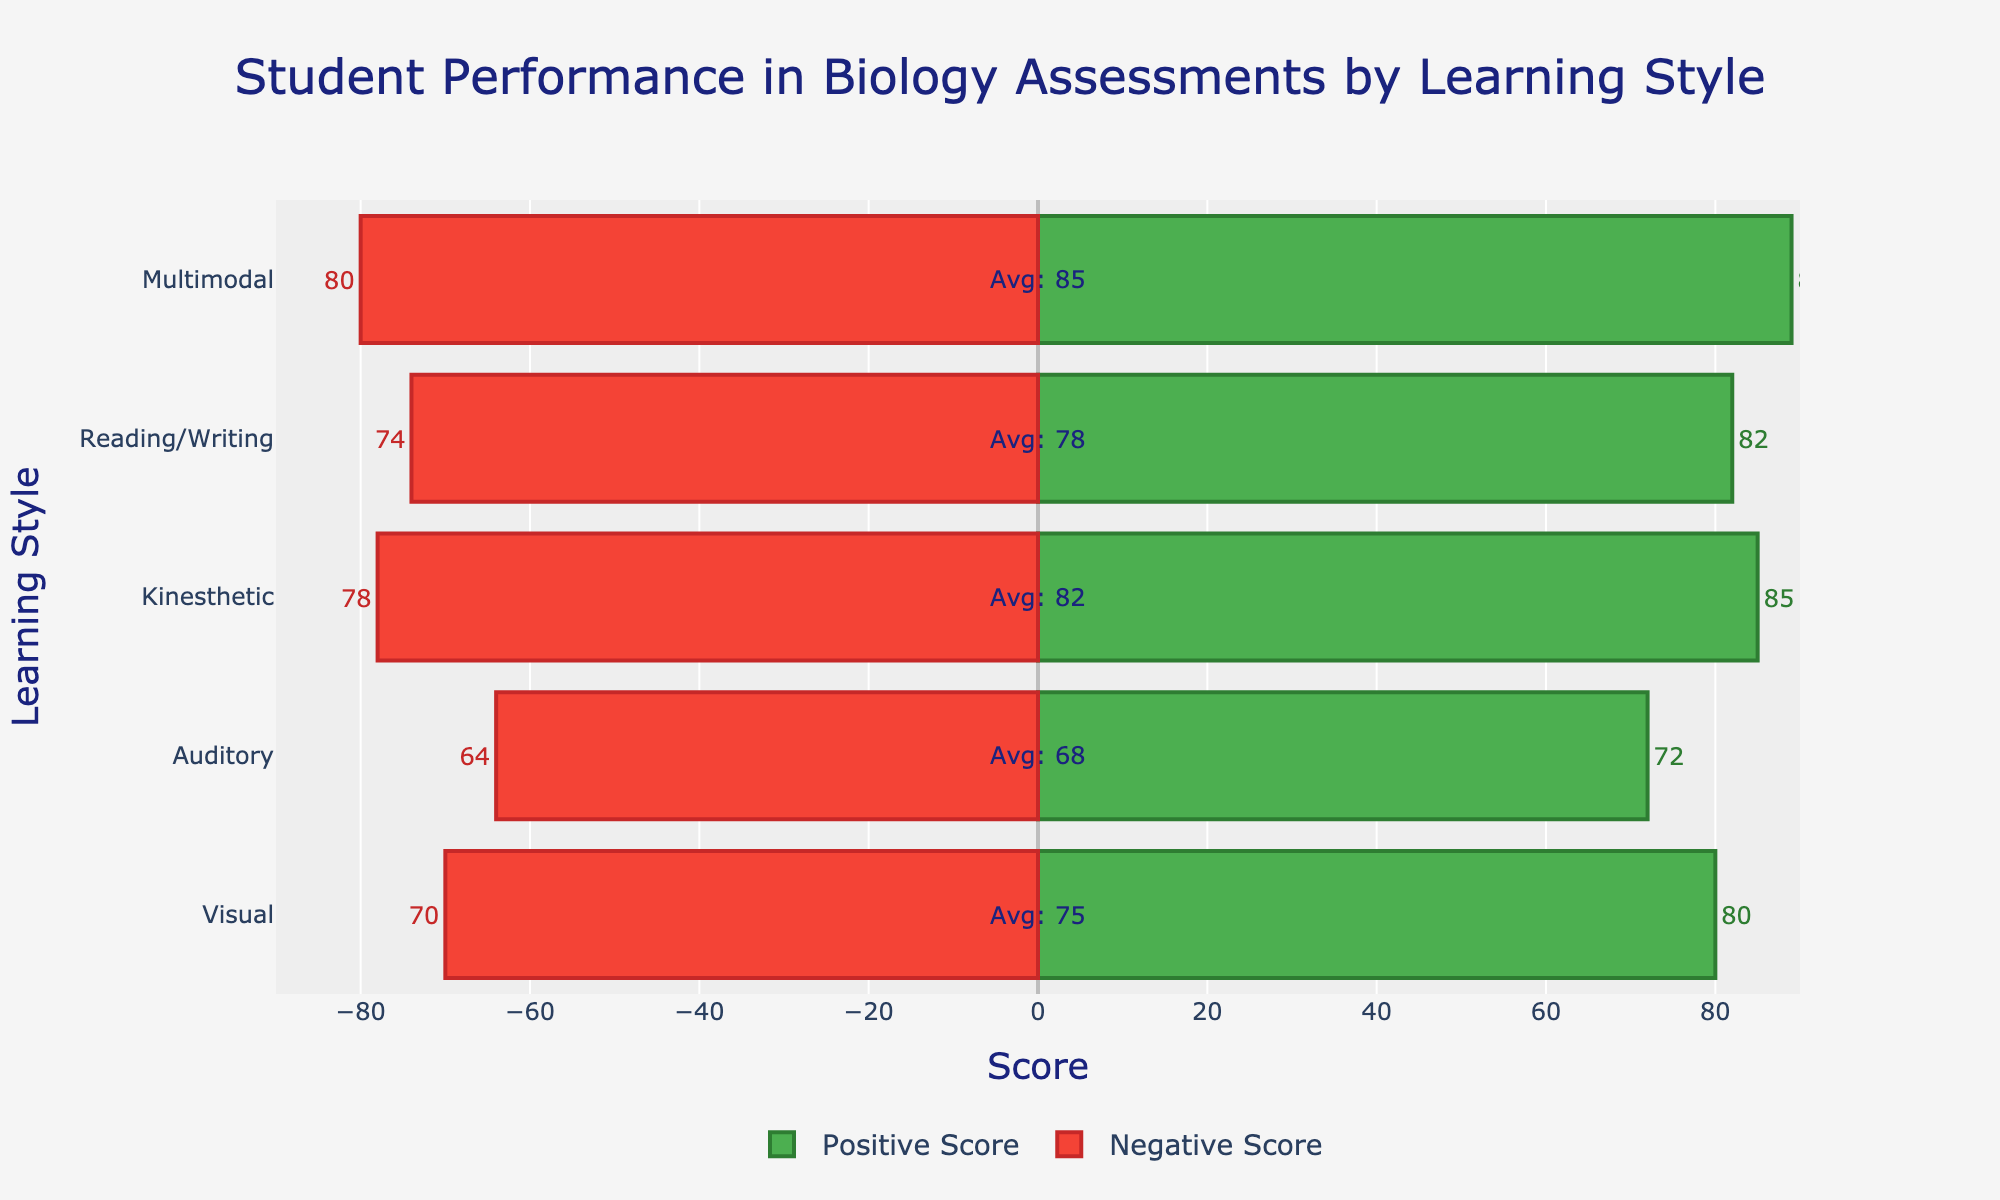What's the average score of the Kinesthetic learning style? The average score is directly annotated next to the Kinesthetic learning style bar.
Answer: 82 Which learning style has the highest positive score? The bar representing the highest positive score is the longest green bar, which is for the Multimodal learning style.
Answer: Multimodal What is the difference between the positive score and negative score of the Auditory learning style? Subtract the negative score of the Auditory learning style from its positive score: 72 - 64 = 8.
Answer: 8 Which learning style has the smallest difference between positive and negative scores? Calculate the difference for each learning style and find the smallest: 
Visual: 80 - 70 = 10 
Auditory: 72 - 64 = 8 
Kinesthetic: 85 - 78 = 7 
Reading/Writing: 82 - 74 = 8 
Multimodal: 89 - 80 = 9. The smallest difference is for the Kinesthetic learning style.
Answer: Kinesthetic Which learning style has the lowest average score? The bar with the lowest average score annotation is for the Auditory learning style.
Answer: Auditory How does the negative score of the visual learning style compare to the average score of the auditory learning style? The negative score of the Visual learning style (70) is greater than the average score of the Auditory learning style (68).
Answer: Visual's negative score is greater What is the combined average score of Visual and Reading/Writing learning styles? Add the average scores of Visual (75) and Reading/Writing (78): 75 + 78 = 153.
Answer: 153 Which learning styles have an average score above 80? Identify learning styles with average scores annotated above 80: 
Kinesthetic: 82 
Multimodal: 85.
Answer: Kinesthetic, Multimodal What's the total sum of the positive scores for all learning styles? Sum the positive scores: 80 (Visual) + 72 (Auditory) + 85 (Kinesthetic) + 82 (Reading/Writing) + 89 (Multimodal) = 408.
Answer: 408 How many learning styles have a positive score greater than 80? Count the learning styles with positive scores greater than 80: 
Kinesthetic: 85 
Reading/Writing: 82 
Multimodal: 89. There are 3 learning styles.
Answer: 3 